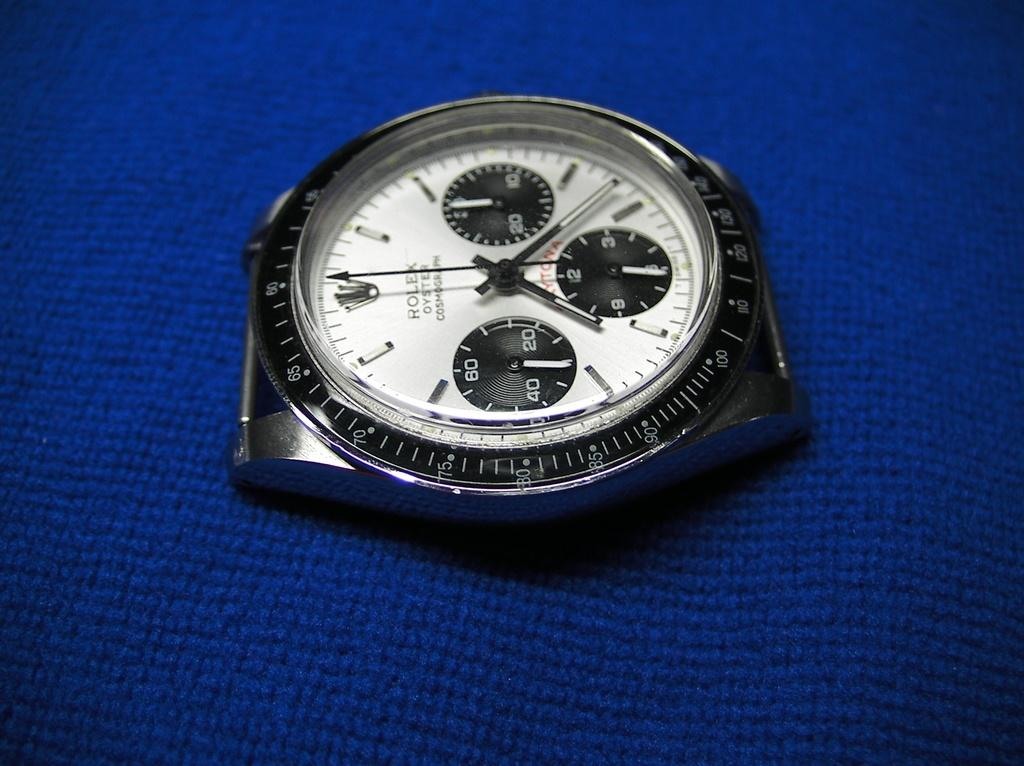<image>
Offer a succinct explanation of the picture presented. A Rolex Oyster Cosmograph watch face on a blue cloth. 